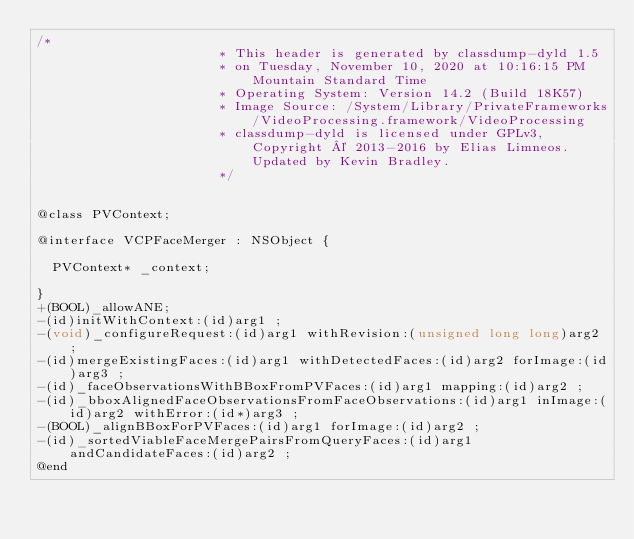<code> <loc_0><loc_0><loc_500><loc_500><_C_>/*
                       * This header is generated by classdump-dyld 1.5
                       * on Tuesday, November 10, 2020 at 10:16:15 PM Mountain Standard Time
                       * Operating System: Version 14.2 (Build 18K57)
                       * Image Source: /System/Library/PrivateFrameworks/VideoProcessing.framework/VideoProcessing
                       * classdump-dyld is licensed under GPLv3, Copyright © 2013-2016 by Elias Limneos. Updated by Kevin Bradley.
                       */


@class PVContext;

@interface VCPFaceMerger : NSObject {

	PVContext* _context;

}
+(BOOL)_allowANE;
-(id)initWithContext:(id)arg1 ;
-(void)_configureRequest:(id)arg1 withRevision:(unsigned long long)arg2 ;
-(id)mergeExistingFaces:(id)arg1 withDetectedFaces:(id)arg2 forImage:(id)arg3 ;
-(id)_faceObservationsWithBBoxFromPVFaces:(id)arg1 mapping:(id)arg2 ;
-(id)_bboxAlignedFaceObservationsFromFaceObservations:(id)arg1 inImage:(id)arg2 withError:(id*)arg3 ;
-(BOOL)_alignBBoxForPVFaces:(id)arg1 forImage:(id)arg2 ;
-(id)_sortedViableFaceMergePairsFromQueryFaces:(id)arg1 andCandidateFaces:(id)arg2 ;
@end

</code> 